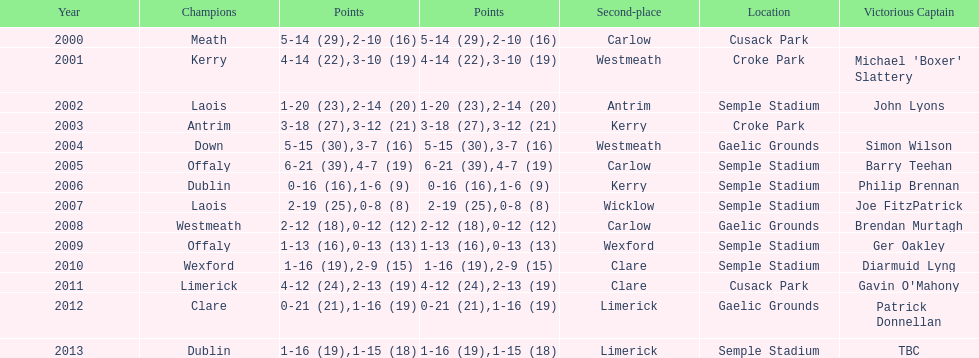Who scored the least? Wicklow. 